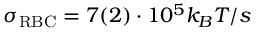<formula> <loc_0><loc_0><loc_500><loc_500>\sigma _ { R B C } = 7 ( 2 ) \cdot 1 0 ^ { 5 } k _ { B } T / s</formula> 